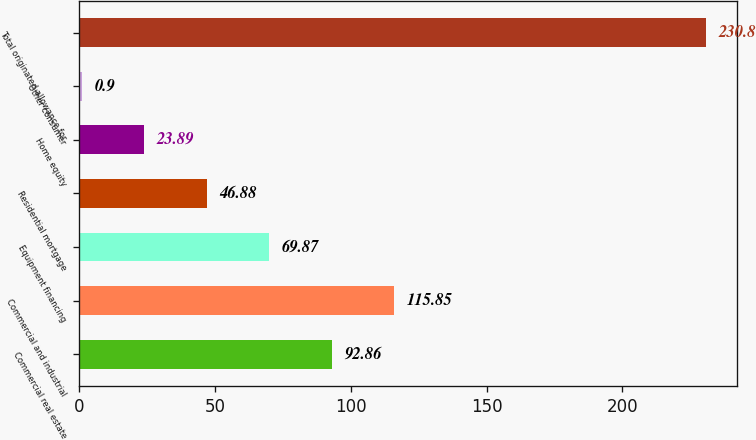<chart> <loc_0><loc_0><loc_500><loc_500><bar_chart><fcel>Commercial real estate<fcel>Commercial and industrial<fcel>Equipment financing<fcel>Residential mortgage<fcel>Home equity<fcel>Other consumer<fcel>Total originated allowance for<nl><fcel>92.86<fcel>115.85<fcel>69.87<fcel>46.88<fcel>23.89<fcel>0.9<fcel>230.8<nl></chart> 